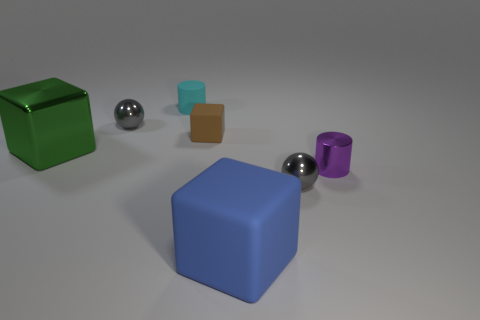Add 3 small cyan cylinders. How many objects exist? 10 Subtract all spheres. How many objects are left? 5 Add 4 brown matte things. How many brown matte things exist? 5 Subtract 0 gray cylinders. How many objects are left? 7 Subtract all big yellow blocks. Subtract all big blue objects. How many objects are left? 6 Add 6 small purple cylinders. How many small purple cylinders are left? 7 